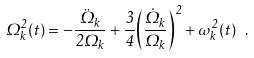Convert formula to latex. <formula><loc_0><loc_0><loc_500><loc_500>\Omega ^ { 2 } _ { k } ( t ) = - \frac { \ddot { \Omega } _ { k } } { 2 \Omega _ { k } } + \frac { 3 } { 4 } { \left ( \frac { \dot { \Omega } _ { k } } { \Omega _ { k } } \right ) } ^ { 2 } + \omega ^ { 2 } _ { k } ( t ) \ .</formula> 